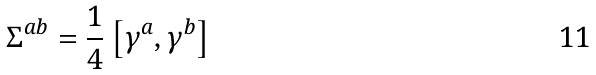<formula> <loc_0><loc_0><loc_500><loc_500>\Sigma ^ { a b } = \frac { 1 } { 4 } \left [ \gamma ^ { a } , \gamma ^ { b } \right ]</formula> 